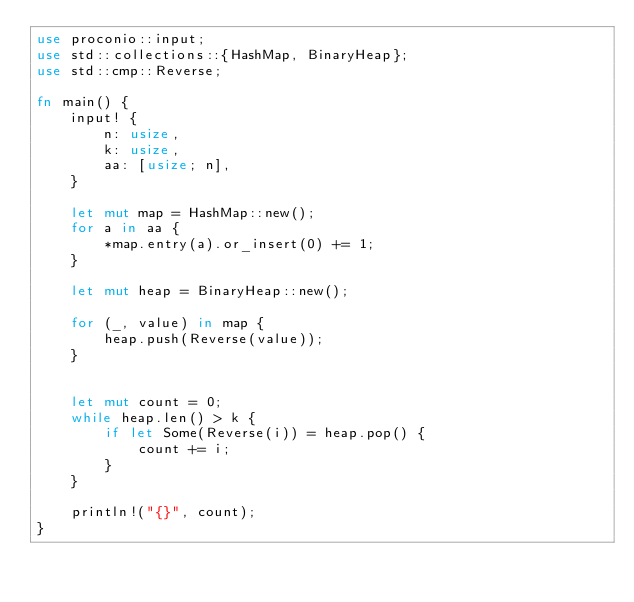Convert code to text. <code><loc_0><loc_0><loc_500><loc_500><_Rust_>use proconio::input;
use std::collections::{HashMap, BinaryHeap};
use std::cmp::Reverse;

fn main() {
    input! {
        n: usize,
        k: usize,
        aa: [usize; n],
    }

    let mut map = HashMap::new();
    for a in aa {
        *map.entry(a).or_insert(0) += 1;
    }

    let mut heap = BinaryHeap::new();

    for (_, value) in map {
        heap.push(Reverse(value));
    }


    let mut count = 0;
    while heap.len() > k {
        if let Some(Reverse(i)) = heap.pop() {
            count += i;
        }
    }

    println!("{}", count);
}
</code> 